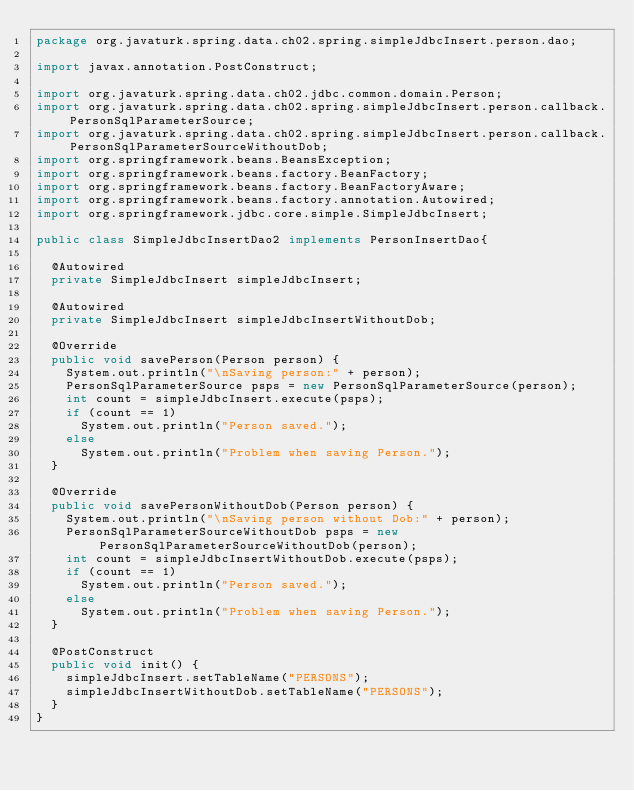<code> <loc_0><loc_0><loc_500><loc_500><_Java_>package org.javaturk.spring.data.ch02.spring.simpleJdbcInsert.person.dao;

import javax.annotation.PostConstruct;

import org.javaturk.spring.data.ch02.jdbc.common.domain.Person;
import org.javaturk.spring.data.ch02.spring.simpleJdbcInsert.person.callback.PersonSqlParameterSource;
import org.javaturk.spring.data.ch02.spring.simpleJdbcInsert.person.callback.PersonSqlParameterSourceWithoutDob;
import org.springframework.beans.BeansException;
import org.springframework.beans.factory.BeanFactory;
import org.springframework.beans.factory.BeanFactoryAware;
import org.springframework.beans.factory.annotation.Autowired;
import org.springframework.jdbc.core.simple.SimpleJdbcInsert;

public class SimpleJdbcInsertDao2 implements PersonInsertDao{
	
	@Autowired
	private SimpleJdbcInsert simpleJdbcInsert;
	
	@Autowired
	private SimpleJdbcInsert simpleJdbcInsertWithoutDob;
	
	@Override
	public void savePerson(Person person) {
		System.out.println("\nSaving person:" + person);
		PersonSqlParameterSource psps = new PersonSqlParameterSource(person);
		int count = simpleJdbcInsert.execute(psps);
		if (count == 1)
			System.out.println("Person saved.");
		else
			System.out.println("Problem when saving Person.");
	}

	@Override
	public void savePersonWithoutDob(Person person) {
		System.out.println("\nSaving person without Dob:" + person);
		PersonSqlParameterSourceWithoutDob psps = new PersonSqlParameterSourceWithoutDob(person);
		int count = simpleJdbcInsertWithoutDob.execute(psps);
		if (count == 1)
			System.out.println("Person saved.");
		else
			System.out.println("Problem when saving Person.");		
	}
	
	@PostConstruct
	public void init() {
		simpleJdbcInsert.setTableName("PERSONS");
		simpleJdbcInsertWithoutDob.setTableName("PERSONS");
	}
}
</code> 